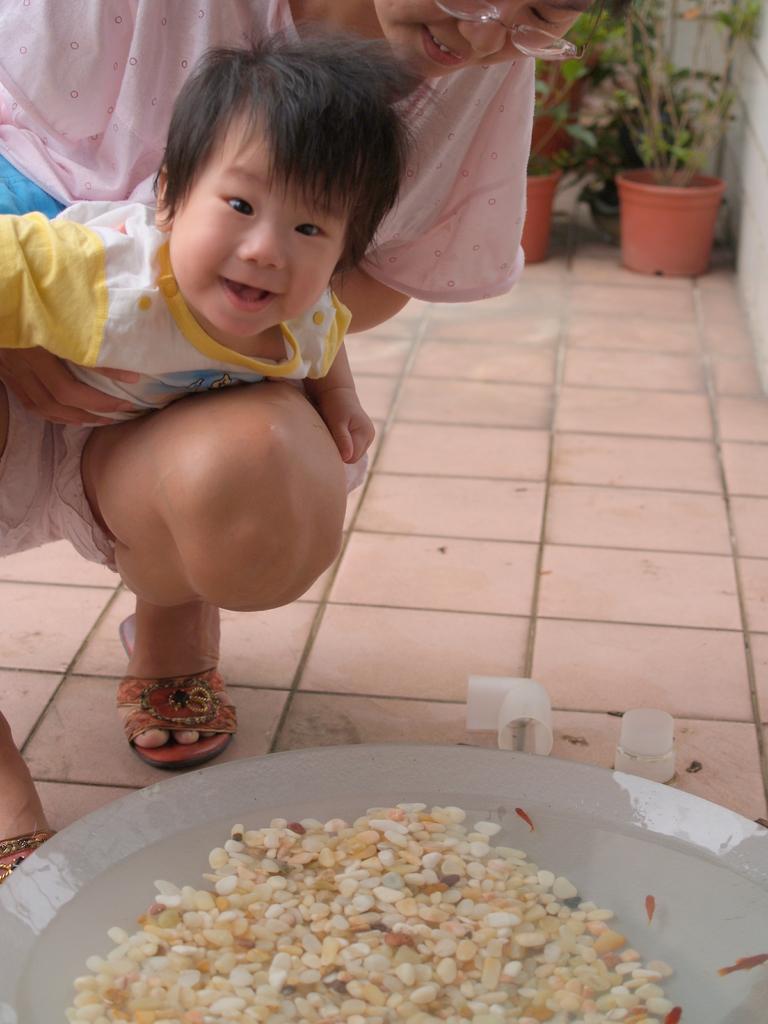Describe this image in one or two sentences. In this picture there is a woman holding a baby in her hands and there are few objects in front of them and there are few plant pots in the right top corner. 